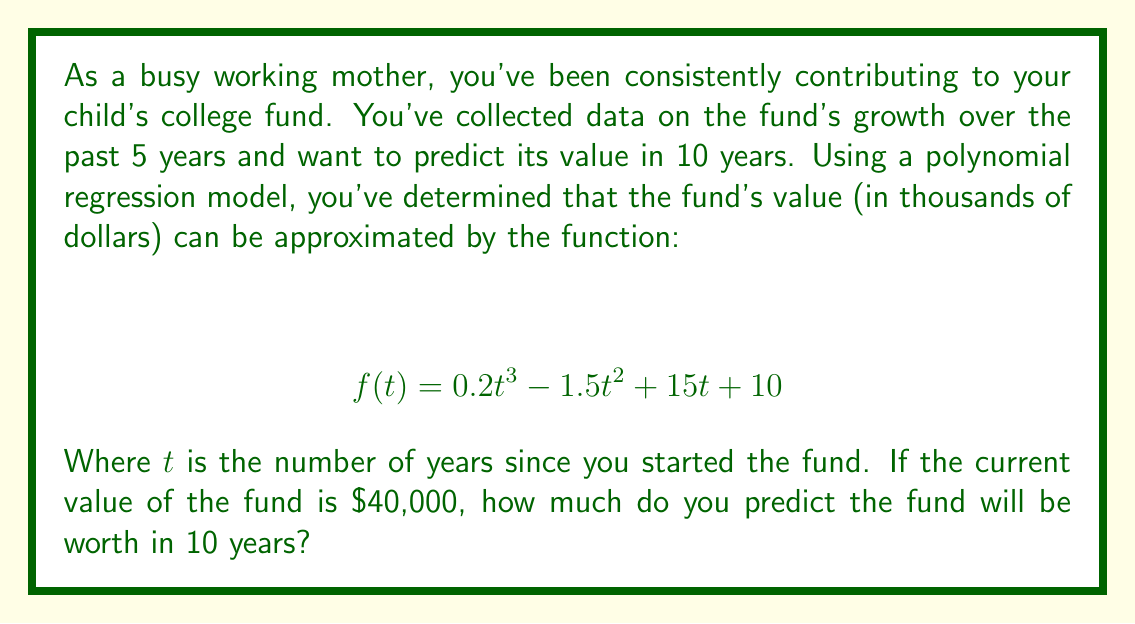Can you answer this question? To solve this problem, we'll follow these steps:

1. Identify the current time ($t$) based on the given information.
2. Calculate the fund's value at $t+10$ years using the polynomial function.
3. Convert the result to dollars.

Step 1: Identify the current time ($t$)
We know that the current value of the fund is $40,000, which is 40 in our function (as it's in thousands of dollars). Let's find $t$ when $f(t) = 40$:

$$ 40 = 0.2t^3 - 1.5t^2 + 15t + 10 $$

Solving this equation, we find that $t \approx 5$ years. This means the fund has been growing for about 5 years.

Step 2: Calculate the fund's value at $t+10$ years
We want to know the value at 15 years (5 current years + 10 future years). Let's substitute $t=15$ into our function:

$$ \begin{align*}
f(15) &= 0.2(15)^3 - 1.5(15)^2 + 15(15) + 10 \\
&= 0.2(3375) - 1.5(225) + 15(15) + 10 \\
&= 675 - 337.5 + 225 + 10 \\
&= 572.5
\end{align*} $$

Step 3: Convert the result to dollars
The function gives the result in thousands of dollars, so we need to multiply by 1000:

$$ 572.5 \times 1000 = 572,500 $$

Therefore, in 10 years, the fund is predicted to be worth $572,500.
Answer: $572,500 